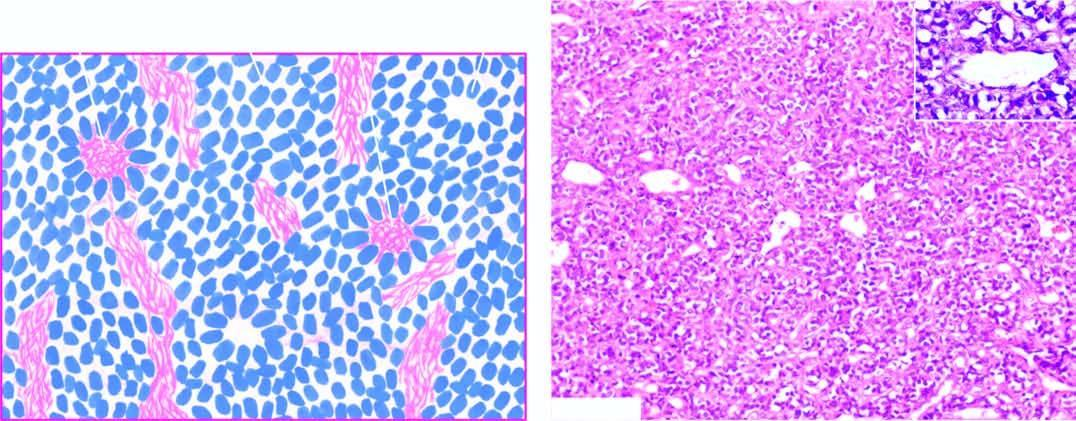what does inset show?
Answer the question using a single word or phrase. A close-up view of pseudorosette 